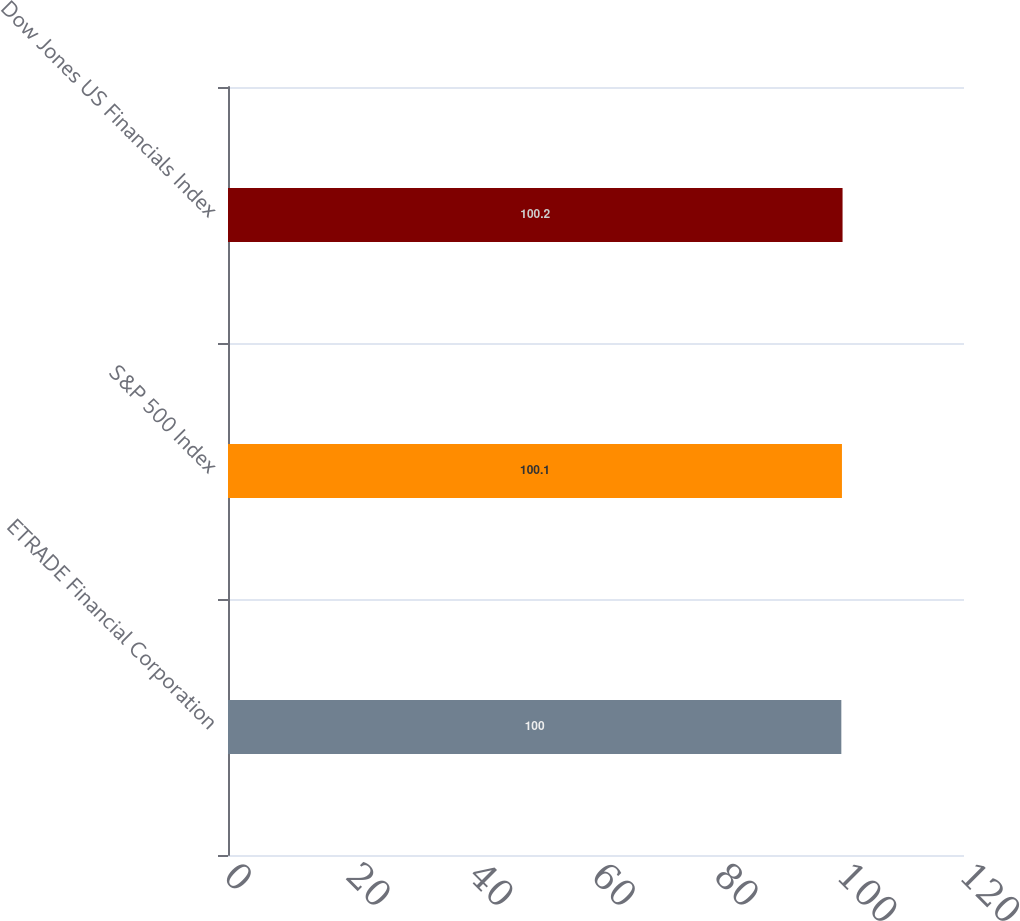Convert chart. <chart><loc_0><loc_0><loc_500><loc_500><bar_chart><fcel>ETRADE Financial Corporation<fcel>S&P 500 Index<fcel>Dow Jones US Financials Index<nl><fcel>100<fcel>100.1<fcel>100.2<nl></chart> 